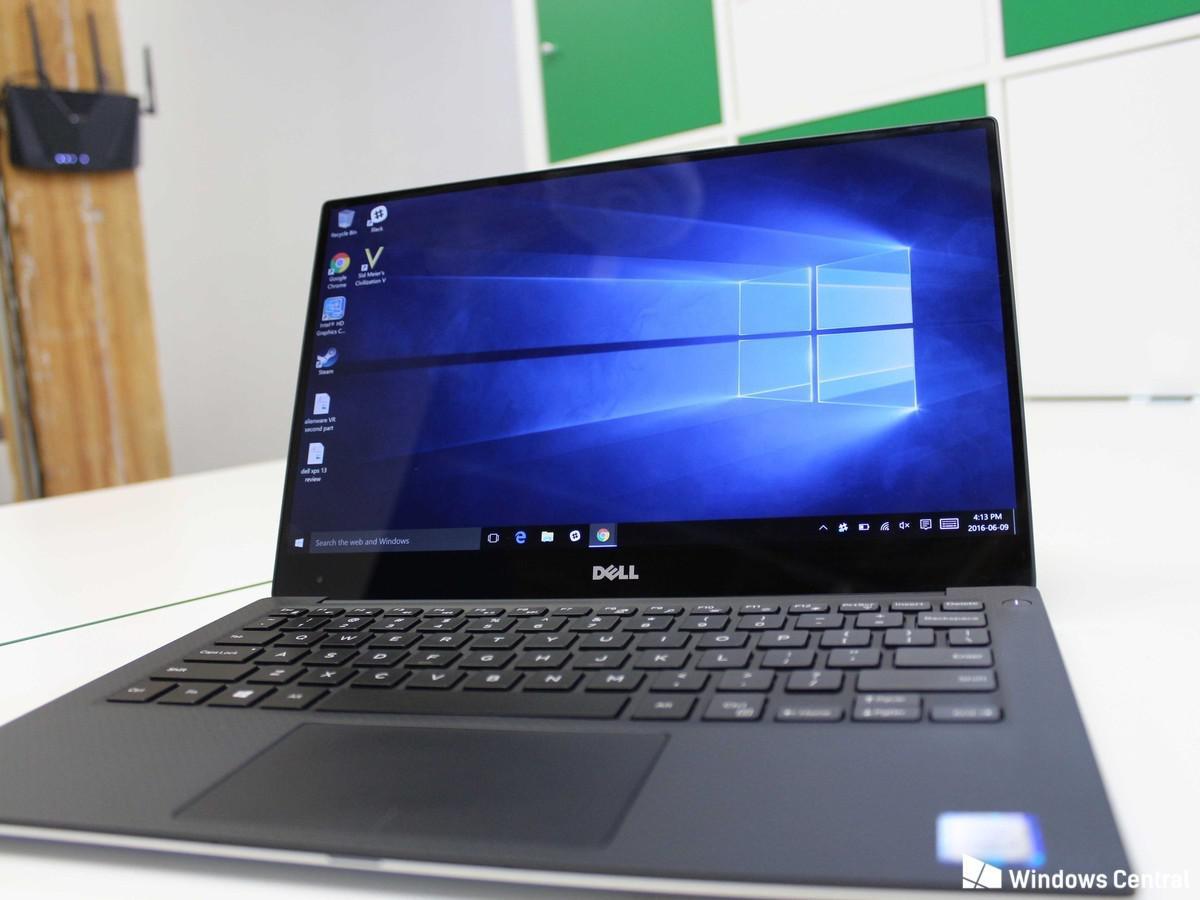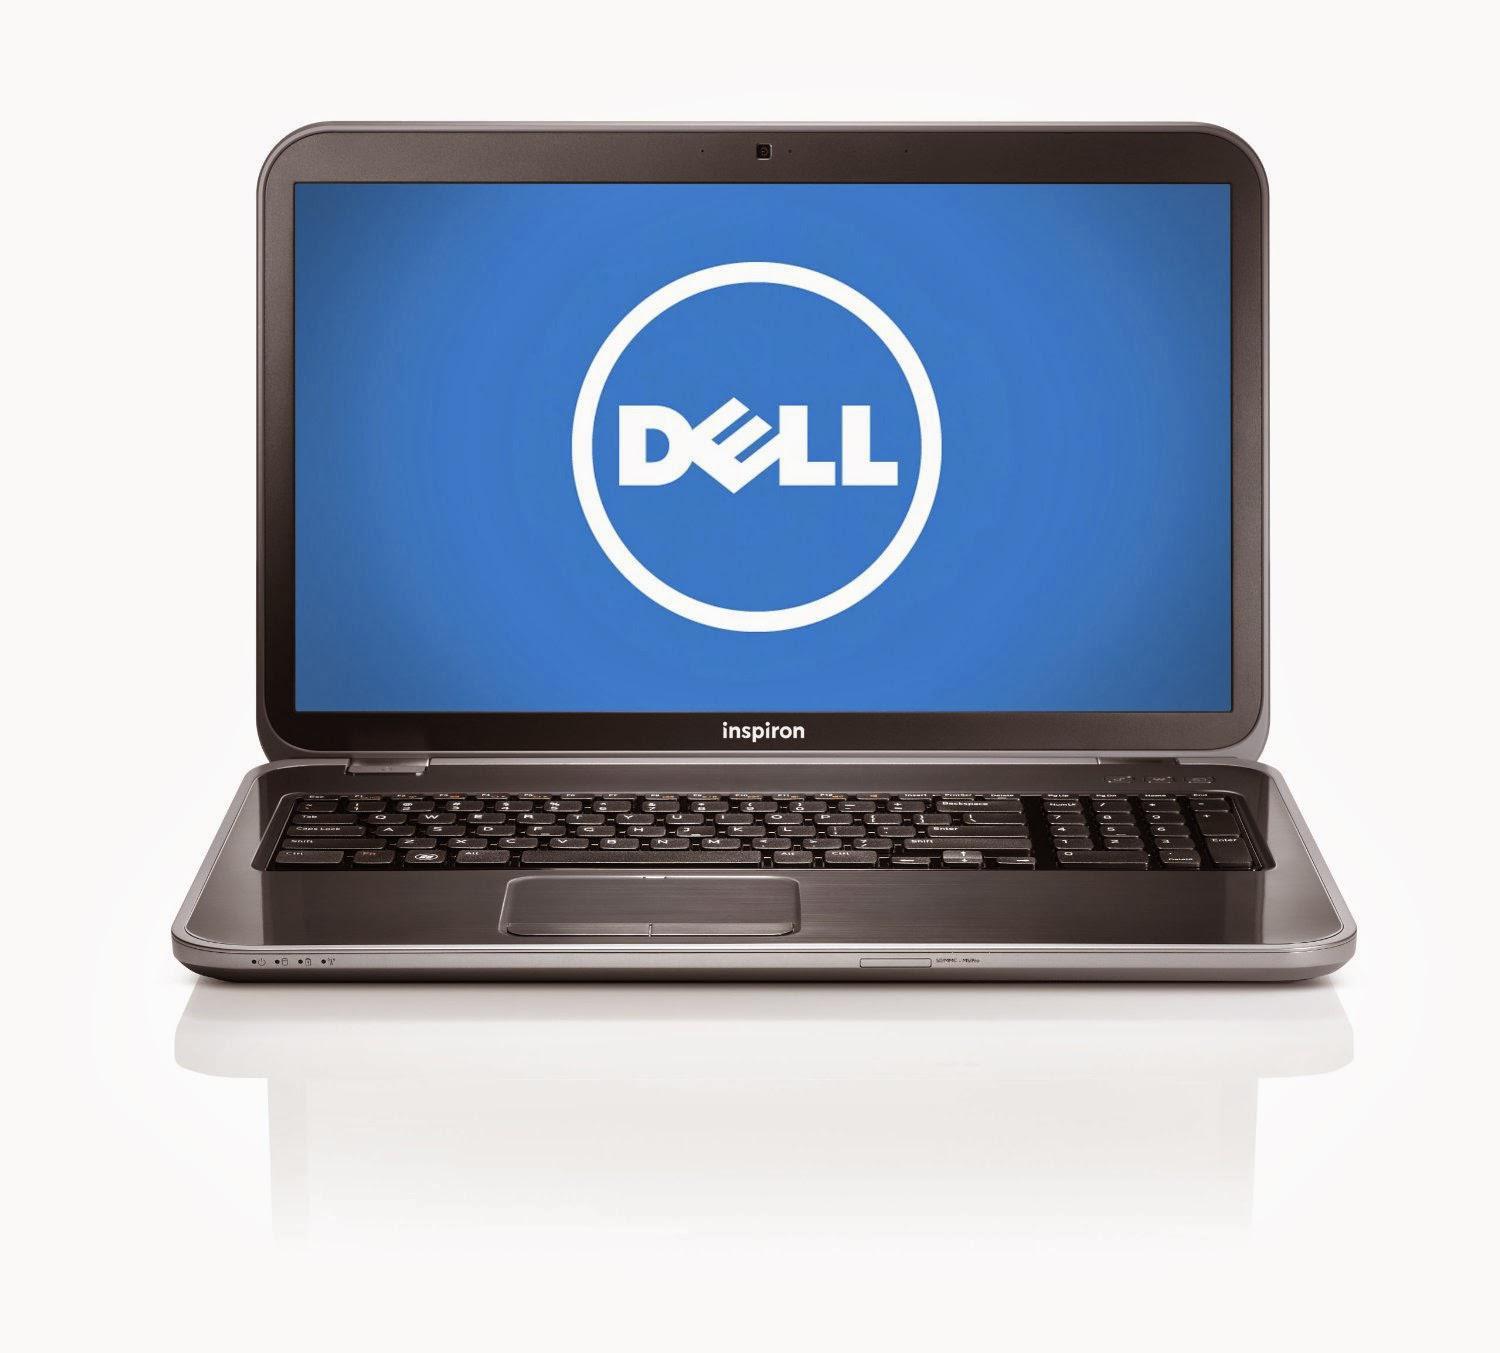The first image is the image on the left, the second image is the image on the right. For the images displayed, is the sentence "One of the images shows an open laptop viewed head-on, with a screen displaying a blue background." factually correct? Answer yes or no. Yes. The first image is the image on the left, the second image is the image on the right. Considering the images on both sides, is "One of the laptops has wallpaper that looks like light shining through a window." valid? Answer yes or no. Yes. 